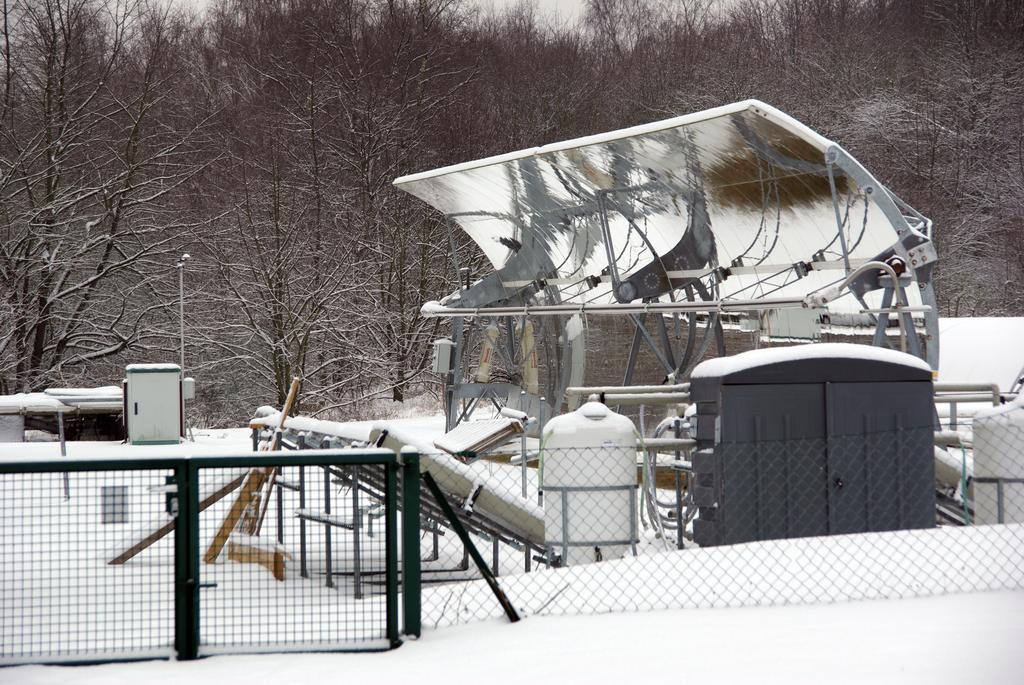In one or two sentences, can you explain what this image depicts? At the bottom we can see snow,fence,gate,cylindrical objects,poles,cupboard and other objects. In the background there are bare trees,sky,metal objects on the right side,poles and other objects. 